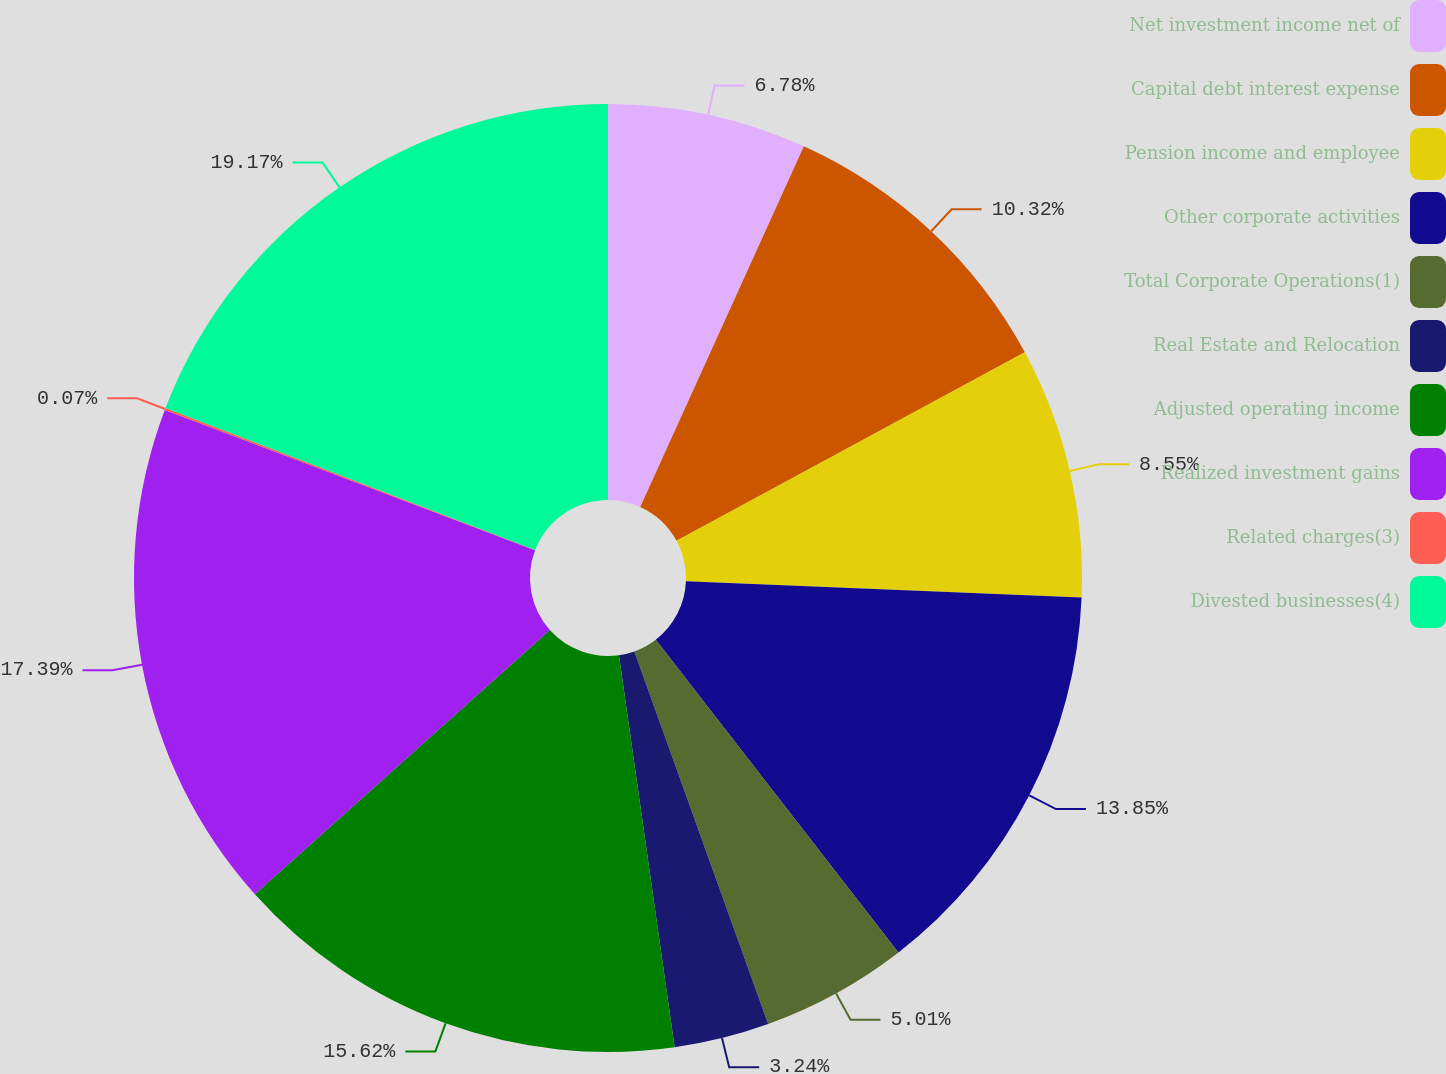<chart> <loc_0><loc_0><loc_500><loc_500><pie_chart><fcel>Net investment income net of<fcel>Capital debt interest expense<fcel>Pension income and employee<fcel>Other corporate activities<fcel>Total Corporate Operations(1)<fcel>Real Estate and Relocation<fcel>Adjusted operating income<fcel>Realized investment gains<fcel>Related charges(3)<fcel>Divested businesses(4)<nl><fcel>6.78%<fcel>10.32%<fcel>8.55%<fcel>13.85%<fcel>5.01%<fcel>3.24%<fcel>15.62%<fcel>17.39%<fcel>0.07%<fcel>19.16%<nl></chart> 